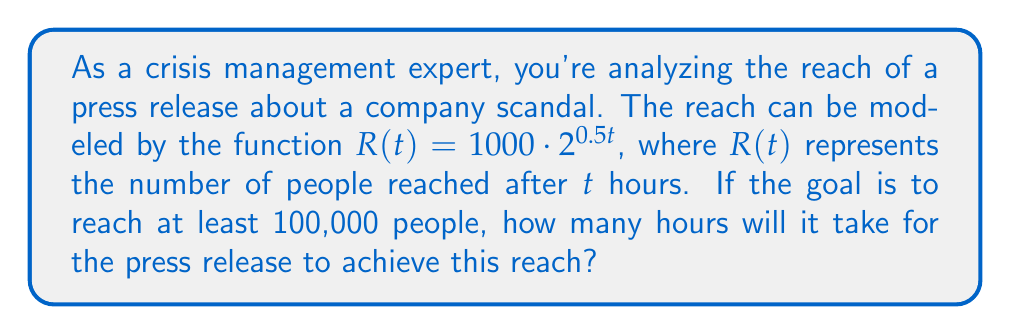What is the answer to this math problem? To solve this problem, we need to use the exponential function given and solve for $t$ when $R(t) = 100,000$. Let's break it down step by step:

1) We start with the equation:
   $R(t) = 1000 \cdot 2^{0.5t}$

2) We want to find $t$ when $R(t) = 100,000$, so we set up the equation:
   $100,000 = 1000 \cdot 2^{0.5t}$

3) Divide both sides by 1000:
   $100 = 2^{0.5t}$

4) Take the logarithm (base 2) of both sides:
   $\log_2(100) = \log_2(2^{0.5t})$

5) Using the logarithm property $\log_a(a^x) = x$, we get:
   $\log_2(100) = 0.5t$

6) Solve for $t$:
   $t = \frac{\log_2(100)}{0.5} = 2\log_2(100)$

7) Calculate the value:
   $t = 2 \cdot \log_2(100) \approx 13.2877$

Therefore, it will take approximately 13.29 hours for the press release to reach 100,000 people.
Answer: $t \approx 13.29$ hours 